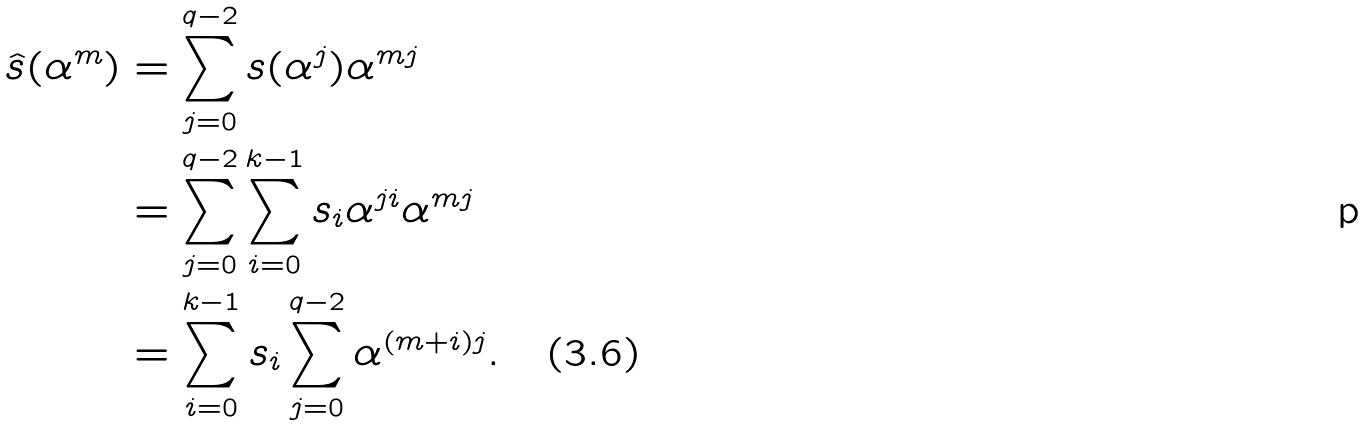<formula> <loc_0><loc_0><loc_500><loc_500>\hat { s } ( \alpha ^ { m } ) & = \sum _ { j = 0 } ^ { q - 2 } s ( \alpha ^ { j } ) \alpha ^ { m j } \\ & = \sum _ { j = 0 } ^ { q - 2 } \sum _ { i = 0 } ^ { k - 1 } s _ { i } \alpha ^ { j i } \alpha ^ { m j } \\ & = \sum _ { i = 0 } ^ { k - 1 } s _ { i } \sum _ { j = 0 } ^ { q - 2 } \alpha ^ { ( m + i ) j } . \quad ( 3 . 6 )</formula> 